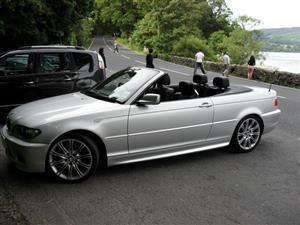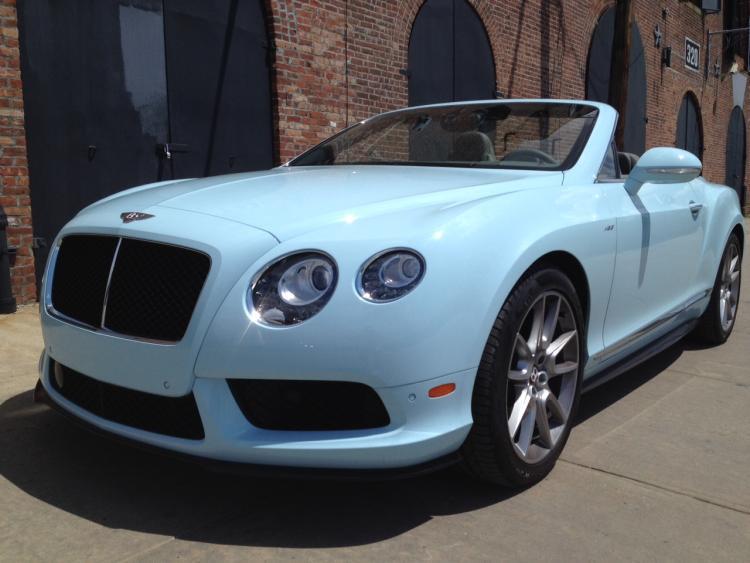The first image is the image on the left, the second image is the image on the right. Considering the images on both sides, is "An image shows the back end and tail light of a driverless white convertible with its top down." valid? Answer yes or no. No. The first image is the image on the left, the second image is the image on the right. Given the left and right images, does the statement "The car on the right is light blue." hold true? Answer yes or no. Yes. 